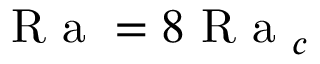<formula> <loc_0><loc_0><loc_500><loc_500>R a = 8 R a _ { c }</formula> 